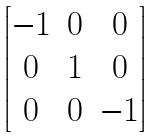Convert formula to latex. <formula><loc_0><loc_0><loc_500><loc_500>\begin{bmatrix} - 1 & 0 & 0 \\ 0 & 1 & 0 \\ 0 & 0 & - 1 \end{bmatrix}</formula> 